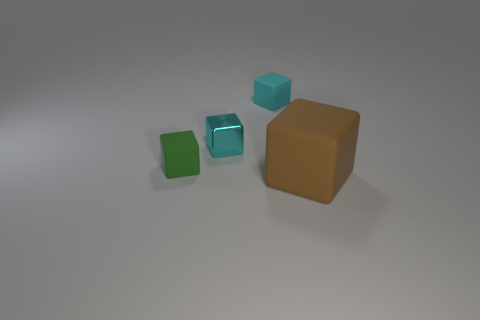Is the number of large things in front of the big matte block greater than the number of tiny matte objects?
Keep it short and to the point. No. What shape is the other big object that is made of the same material as the green thing?
Offer a terse response. Cube. What is the color of the tiny matte thing that is on the left side of the tiny rubber object that is behind the green object?
Keep it short and to the point. Green. Do the big brown thing and the small cyan rubber thing have the same shape?
Offer a terse response. Yes. What material is the large brown thing that is the same shape as the green rubber thing?
Provide a short and direct response. Rubber. Is there a block that is left of the small cyan object in front of the tiny matte block that is on the right side of the small green rubber object?
Give a very brief answer. Yes. There is a big object; is its shape the same as the small matte thing behind the green rubber thing?
Your answer should be very brief. Yes. Are there any other things of the same color as the small shiny thing?
Provide a succinct answer. Yes. There is a object in front of the green cube; does it have the same color as the matte object that is behind the tiny green cube?
Make the answer very short. No. Are any small cyan metallic blocks visible?
Ensure brevity in your answer.  Yes. 